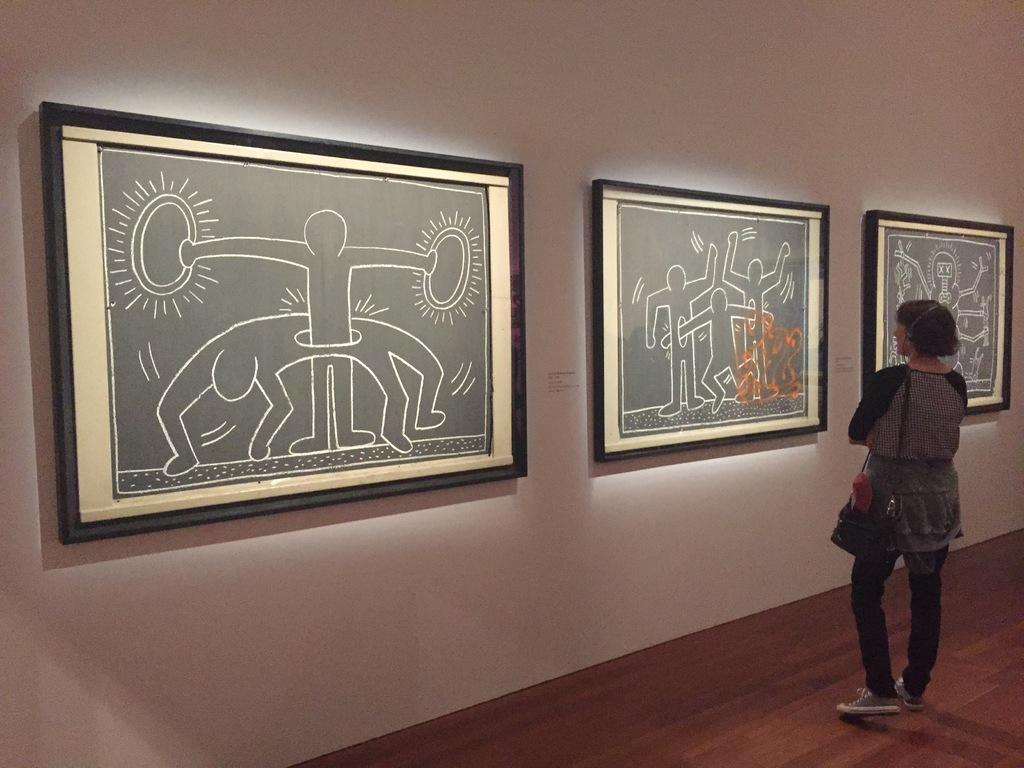Who is present in the image? There is a woman in the image. Where is the woman located in the image? The woman is standing in the right corner. What can be seen on the wall in front of the woman? There are photo frames attached to the wall in front of the woman. What type of bell can be heard ringing in the image? There is no bell present in the image, and therefore no sound can be heard. 